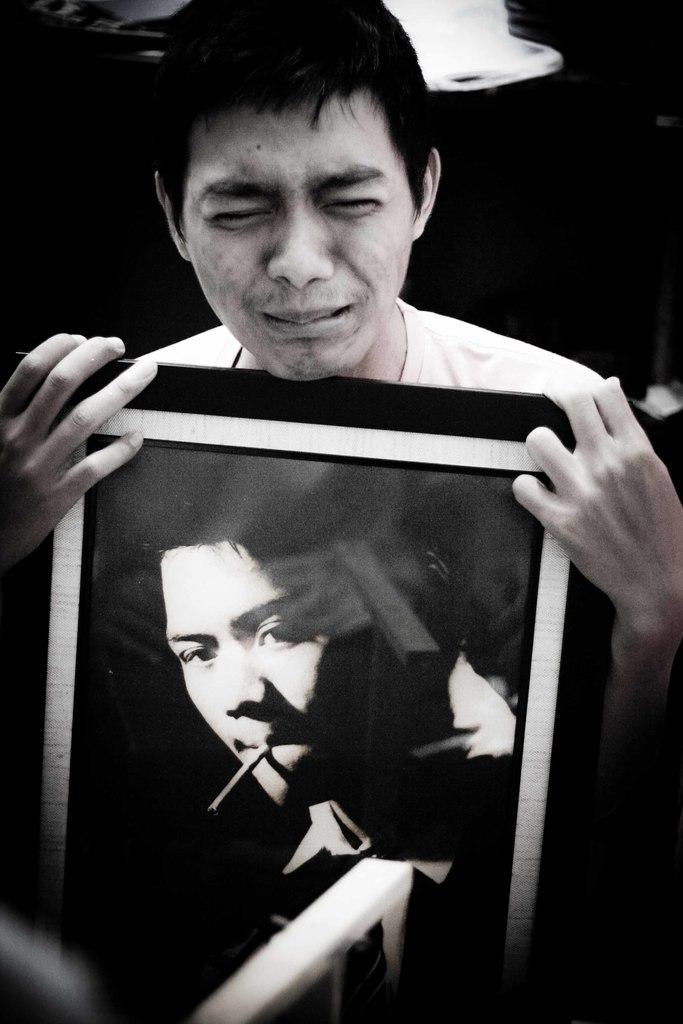Describe this image in one or two sentences. In this picture there is a man holding a picture frame in his hand. There is a picture of a person on the frame. The background is dark. 